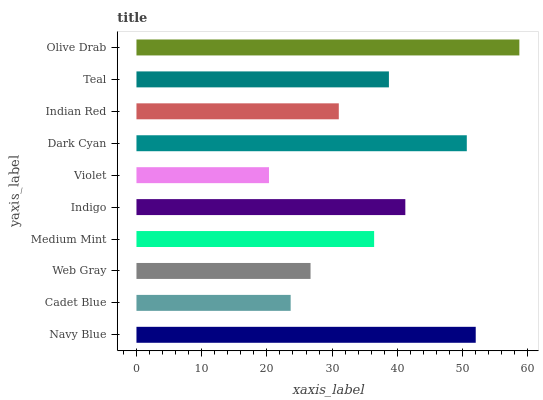Is Violet the minimum?
Answer yes or no. Yes. Is Olive Drab the maximum?
Answer yes or no. Yes. Is Cadet Blue the minimum?
Answer yes or no. No. Is Cadet Blue the maximum?
Answer yes or no. No. Is Navy Blue greater than Cadet Blue?
Answer yes or no. Yes. Is Cadet Blue less than Navy Blue?
Answer yes or no. Yes. Is Cadet Blue greater than Navy Blue?
Answer yes or no. No. Is Navy Blue less than Cadet Blue?
Answer yes or no. No. Is Teal the high median?
Answer yes or no. Yes. Is Medium Mint the low median?
Answer yes or no. Yes. Is Navy Blue the high median?
Answer yes or no. No. Is Olive Drab the low median?
Answer yes or no. No. 